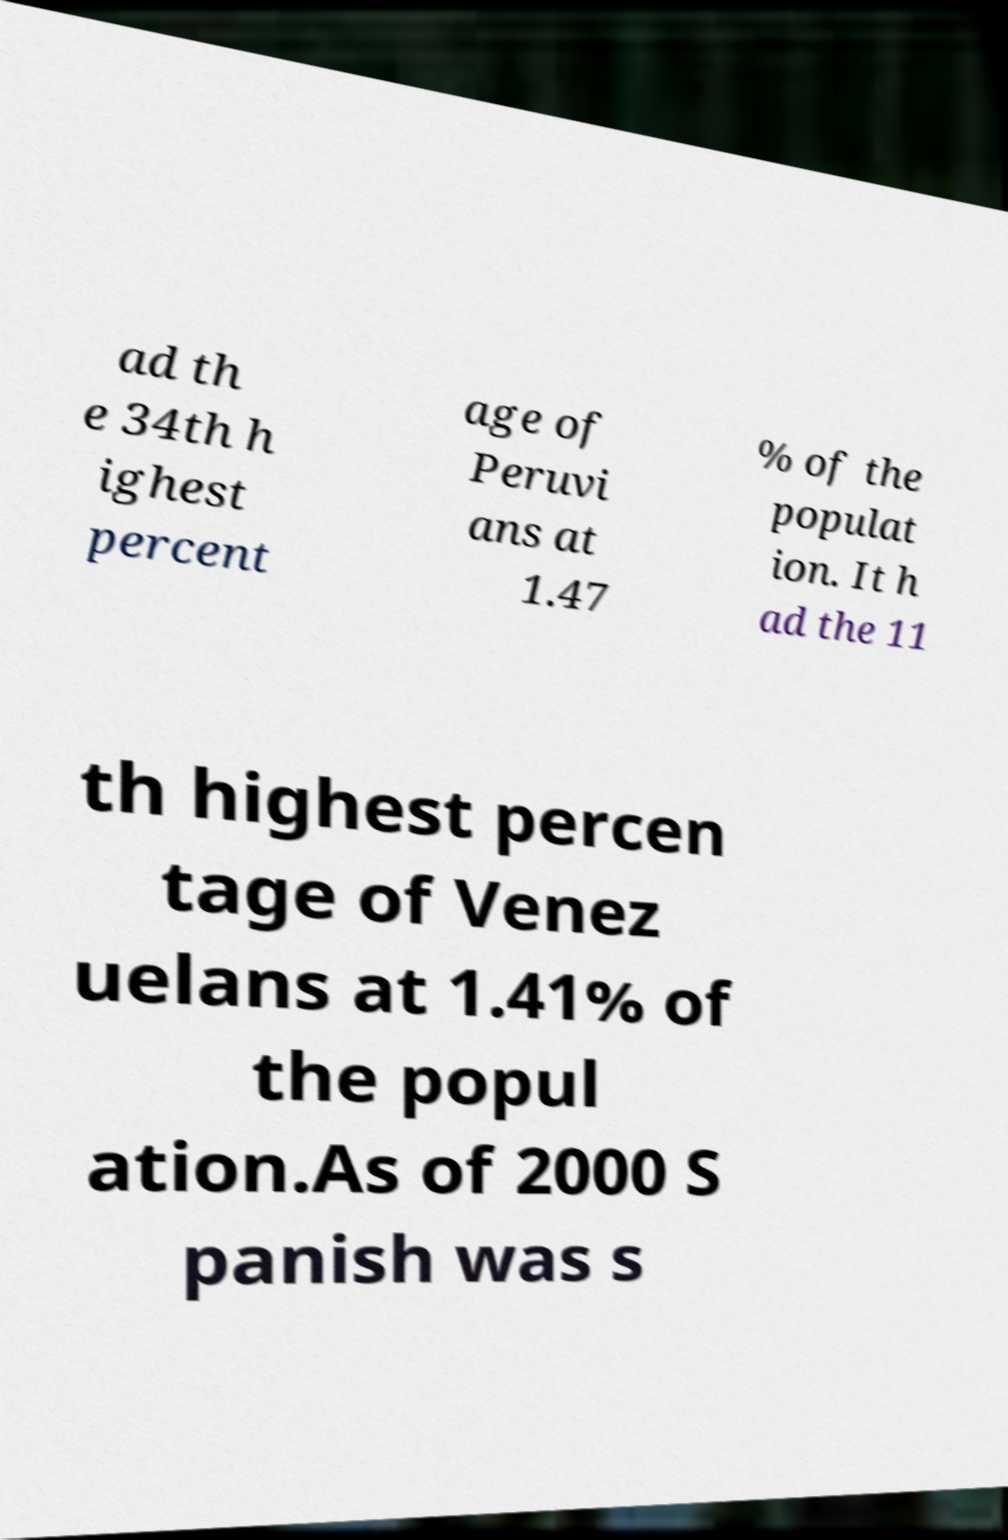What messages or text are displayed in this image? I need them in a readable, typed format. ad th e 34th h ighest percent age of Peruvi ans at 1.47 % of the populat ion. It h ad the 11 th highest percen tage of Venez uelans at 1.41% of the popul ation.As of 2000 S panish was s 